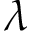Convert formula to latex. <formula><loc_0><loc_0><loc_500><loc_500>\lambda</formula> 